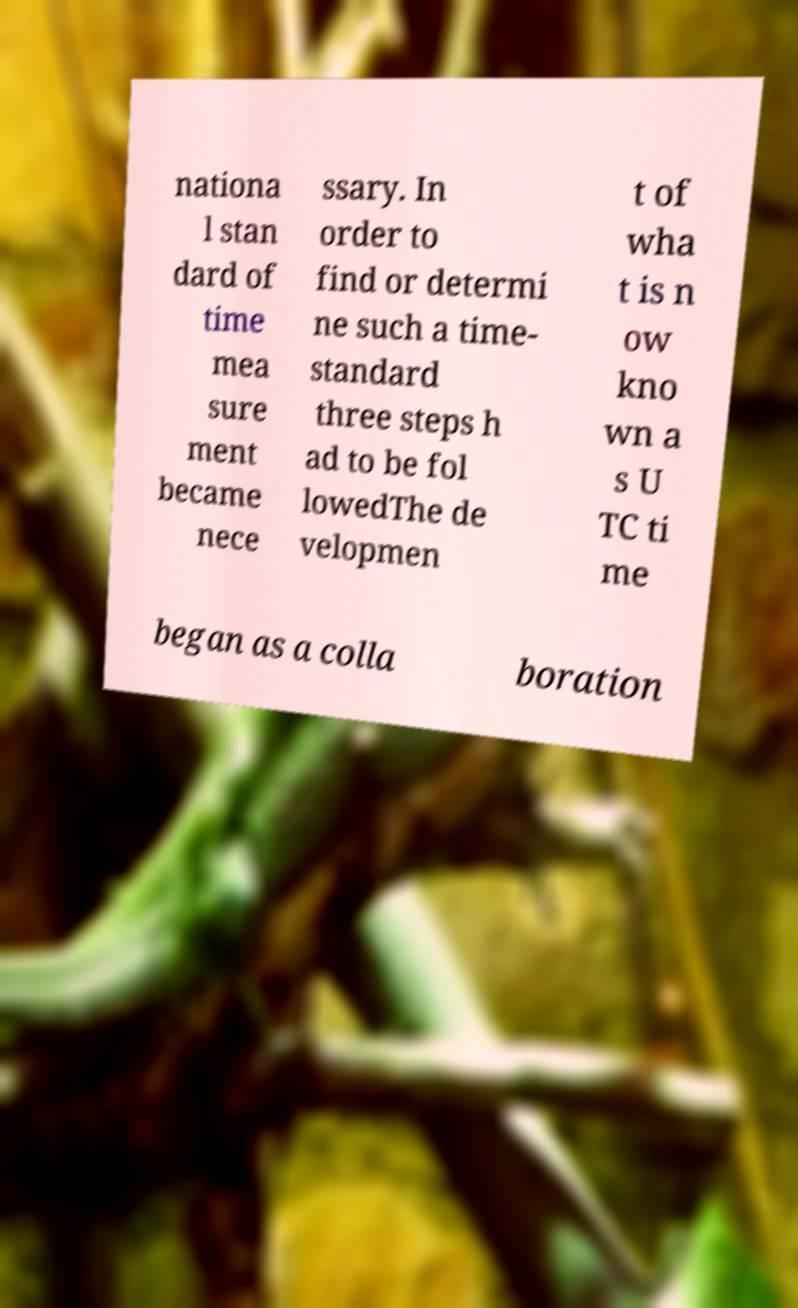Can you accurately transcribe the text from the provided image for me? nationa l stan dard of time mea sure ment became nece ssary. In order to find or determi ne such a time- standard three steps h ad to be fol lowedThe de velopmen t of wha t is n ow kno wn a s U TC ti me began as a colla boration 